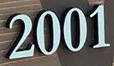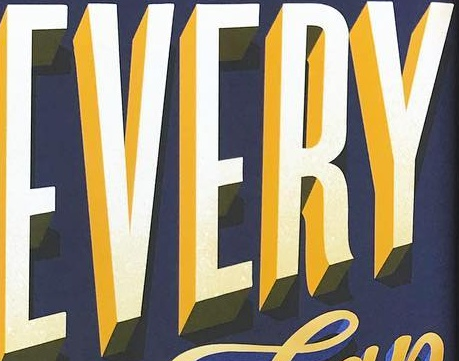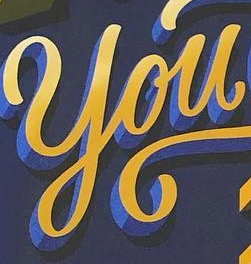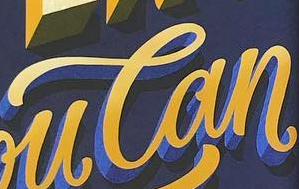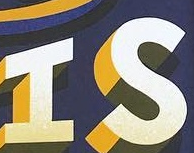What words are shown in these images in order, separated by a semicolon? 2001; EVERY; You; Can; IS 